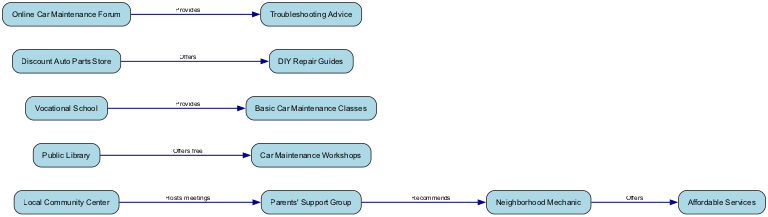What are some community resources for car services? The diagram shows various nodes connected by edges which represent the relationships. The nodes include the Local Community Center, Public Library, Parents' Support Group, Vocational School, Discount Auto Parts Store, Online Car Maintenance Forum, and Neighborhood Mechanic, all of which serve as local resources for affordable car services.
Answer: Local Community Center, Public Library, Parents' Support Group, Vocational School, Discount Auto Parts Store, Online Car Maintenance Forum, Neighborhood Mechanic Which node offers Basic Car Maintenance Classes? In the diagram, the edge from the Vocational School leads to the Basic Car Maintenance Classes node, indicating that the Vocational School provides these classes.
Answer: Vocational School How many edges are there in the diagram? By counting all the connections (edges) between the nodes in the diagram, we find there are a total of 7 edges connecting various resources.
Answer: 7 Which node is recommended by the Parents' Support Group? The diagram shows an edge from the Parents' Support Group to the Neighborhood Mechanic, indicating that this mechanic is recommended by the group.
Answer: Neighborhood Mechanic What type of advice does the Online Car Maintenance Forum provide? An edge from the Online Car Maintenance Forum to the Troubleshooting Advice node indicates that the forum provides this type of advice.
Answer: Troubleshooting Advice What resource offers DIY Repair Guides? The diagram indicates that the Discount Auto Parts Store has an edge leading to the DIY Repair Guides node, showing it offers these guides.
Answer: Discount Auto Parts Store Which community resource hosts meetings? Looking at the diagram, the Local Community Center has an edge leading to the Parents' Support Group indicating that it hosts their meetings.
Answer: Local Community Center What do the edges represent in this diagram? The edges in the diagram represent the relationships and connections between different resources and the services they offer.
Answer: Relationships Which resource offers Affordable Services? The Neighborhood Mechanic is directly connected to the Affordable Services node, indicating that it offers affordable car services.
Answer: Neighborhood Mechanic 